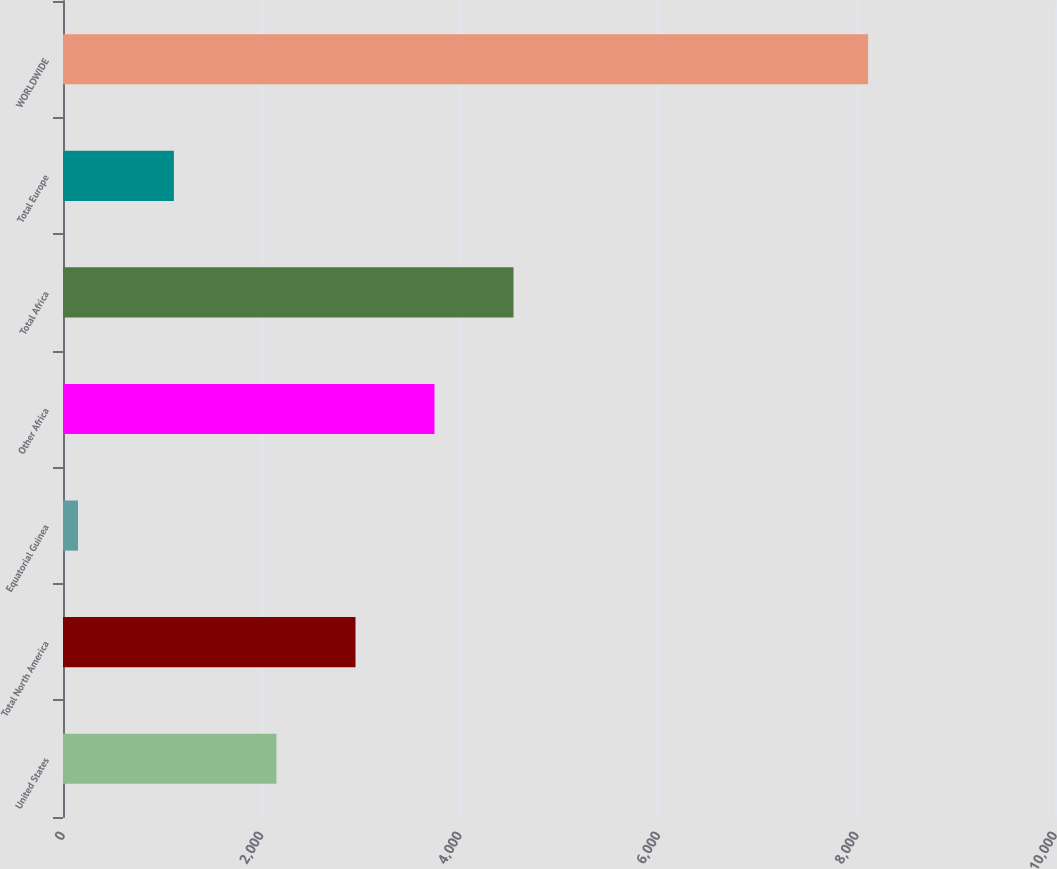Convert chart to OTSL. <chart><loc_0><loc_0><loc_500><loc_500><bar_chart><fcel>United States<fcel>Total North America<fcel>Equatorial Guinea<fcel>Other Africa<fcel>Total Africa<fcel>Total Europe<fcel>WORLDWIDE<nl><fcel>2152<fcel>2948.5<fcel>151<fcel>3745<fcel>4541.5<fcel>1118<fcel>8116<nl></chart> 